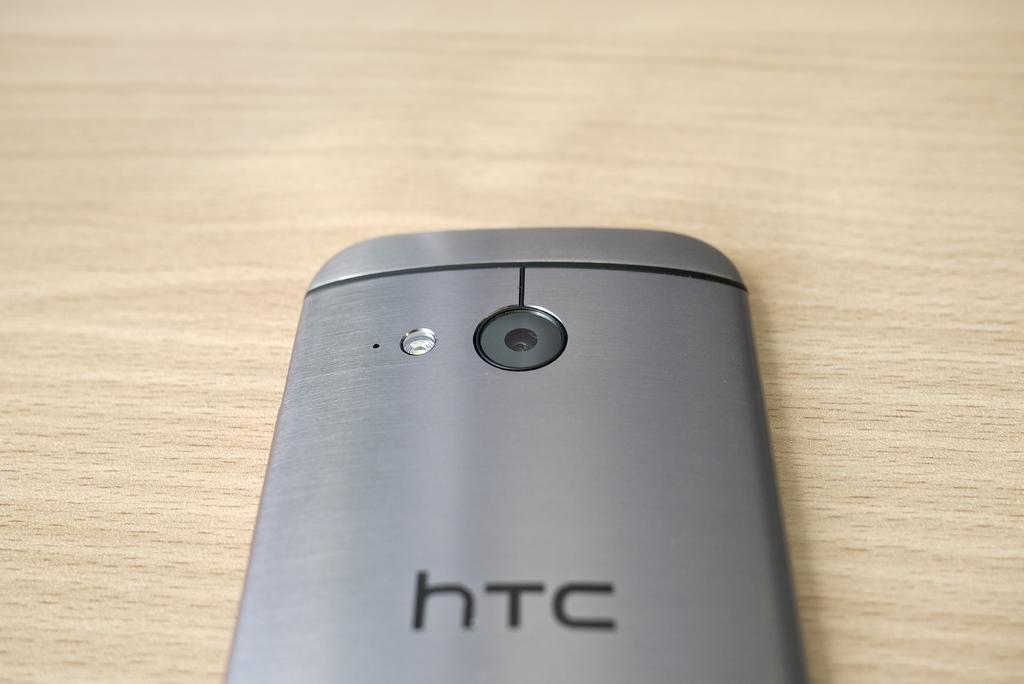<image>
Describe the image concisely. back of brushed metal htc phone on a wood surface 